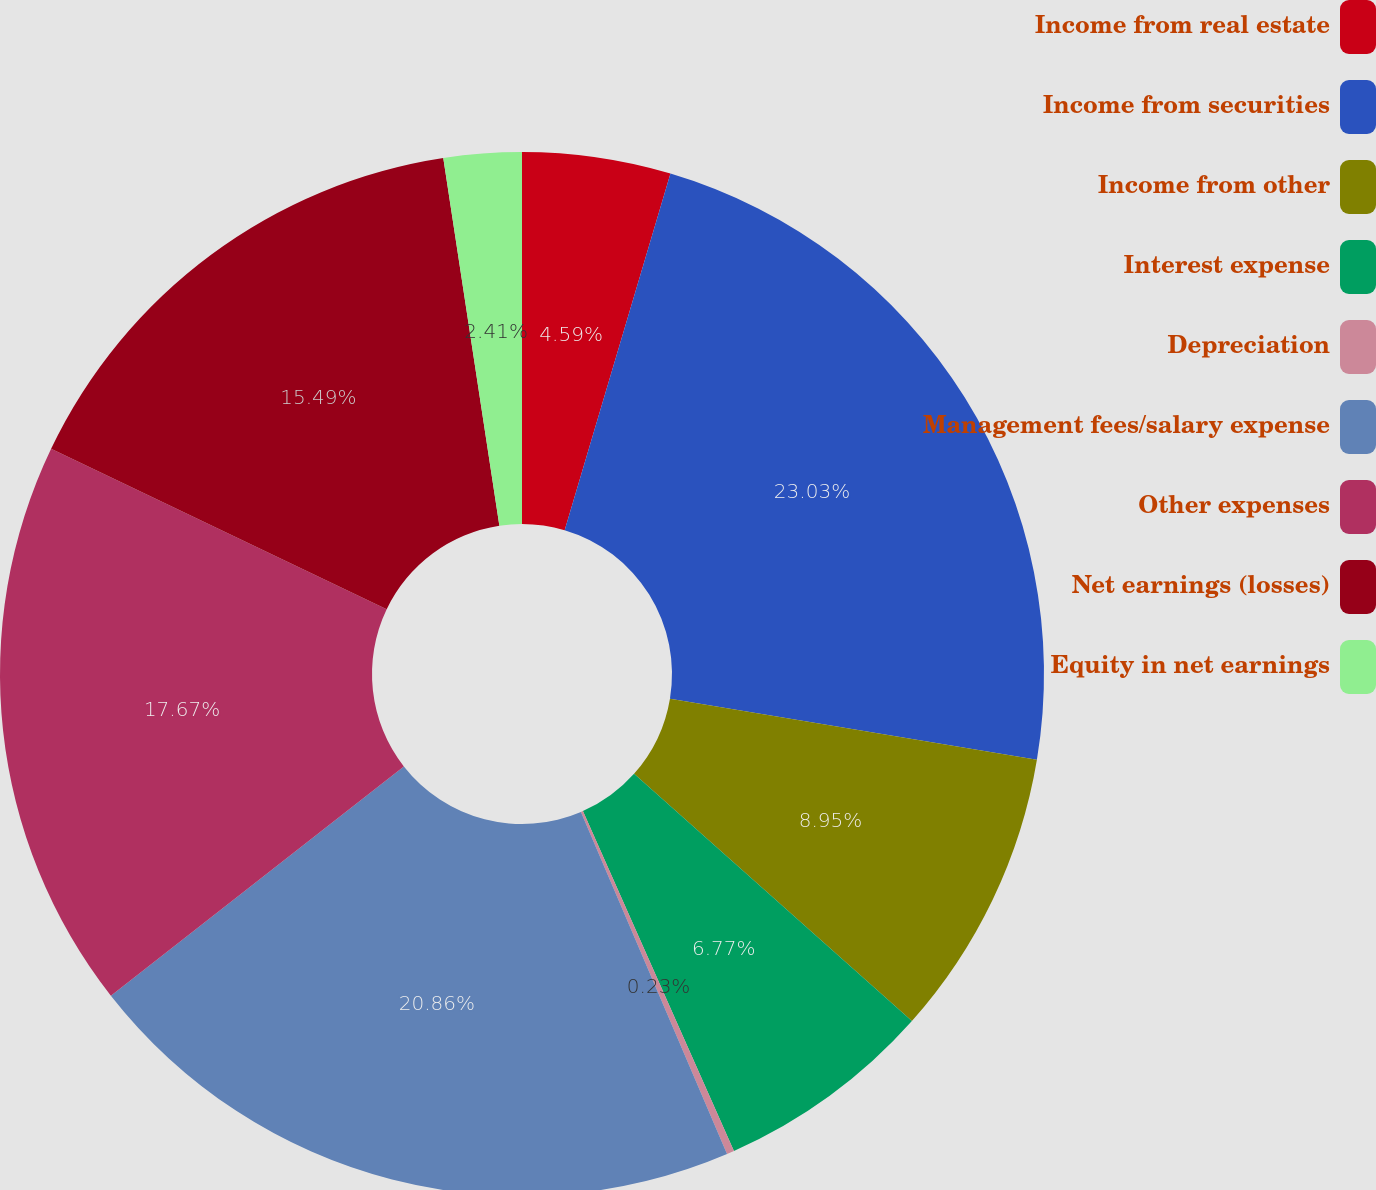<chart> <loc_0><loc_0><loc_500><loc_500><pie_chart><fcel>Income from real estate<fcel>Income from securities<fcel>Income from other<fcel>Interest expense<fcel>Depreciation<fcel>Management fees/salary expense<fcel>Other expenses<fcel>Net earnings (losses)<fcel>Equity in net earnings<nl><fcel>4.59%<fcel>23.04%<fcel>8.95%<fcel>6.77%<fcel>0.23%<fcel>20.86%<fcel>17.67%<fcel>15.49%<fcel>2.41%<nl></chart> 